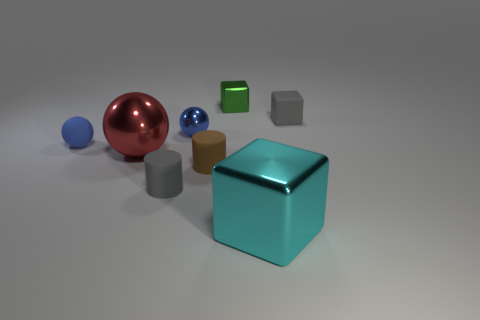Subtract all tiny spheres. How many spheres are left? 1 Subtract all brown cylinders. How many cylinders are left? 1 Subtract all spheres. How many objects are left? 5 Add 2 small yellow metallic cylinders. How many objects exist? 10 Subtract 0 green cylinders. How many objects are left? 8 Subtract all gray spheres. Subtract all brown blocks. How many spheres are left? 3 Subtract all cyan spheres. How many green blocks are left? 1 Subtract all large cyan shiny cubes. Subtract all small cyan objects. How many objects are left? 7 Add 5 gray cubes. How many gray cubes are left? 6 Add 3 big balls. How many big balls exist? 4 